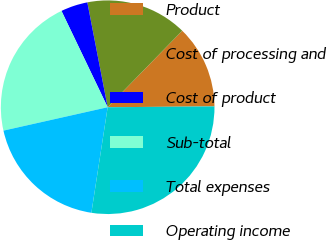Convert chart to OTSL. <chart><loc_0><loc_0><loc_500><loc_500><pie_chart><fcel>Product<fcel>Cost of processing and<fcel>Cost of product<fcel>Sub-total<fcel>Total expenses<fcel>Operating income<nl><fcel>12.58%<fcel>15.35%<fcel>4.07%<fcel>21.4%<fcel>19.05%<fcel>27.56%<nl></chart> 